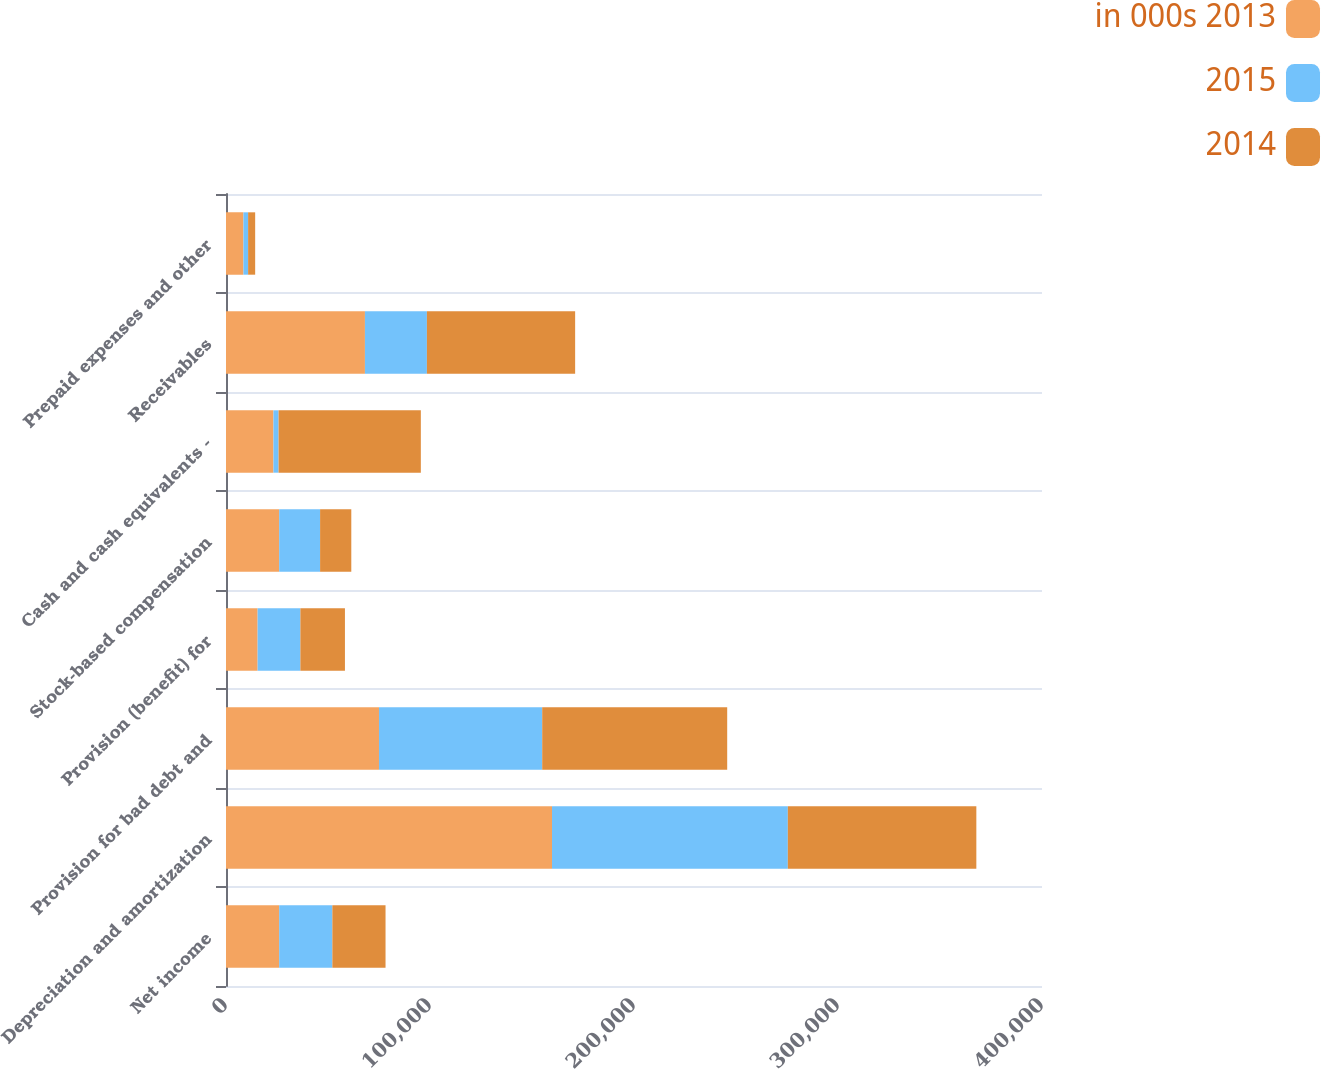Convert chart to OTSL. <chart><loc_0><loc_0><loc_500><loc_500><stacked_bar_chart><ecel><fcel>Net income<fcel>Depreciation and amortization<fcel>Provision for bad debt and<fcel>Provision (benefit) for<fcel>Stock-based compensation<fcel>Cash and cash equivalents -<fcel>Receivables<fcel>Prepaid expenses and other<nl><fcel>in 000s 2013<fcel>26068<fcel>159804<fcel>74993<fcel>15502<fcel>26068<fcel>23252<fcel>68109<fcel>8542<nl><fcel>2015<fcel>26068<fcel>115604<fcel>80007<fcel>20958<fcel>20058<fcel>2522<fcel>30376<fcel>2293<nl><fcel>2014<fcel>26068<fcel>92407<fcel>90685<fcel>21846<fcel>15293<fcel>69737<fcel>72662<fcel>3464<nl></chart> 